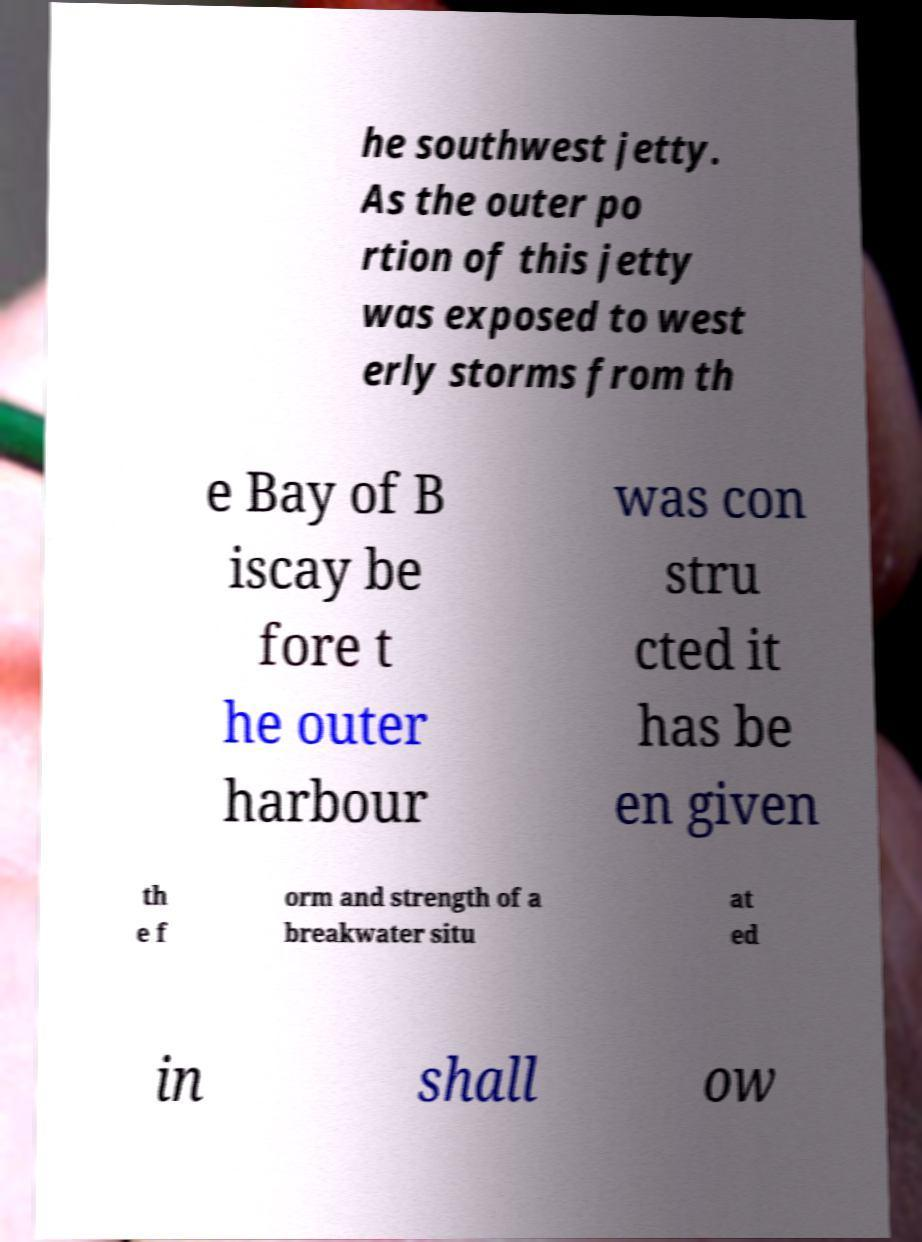Could you assist in decoding the text presented in this image and type it out clearly? he southwest jetty. As the outer po rtion of this jetty was exposed to west erly storms from th e Bay of B iscay be fore t he outer harbour was con stru cted it has be en given th e f orm and strength of a breakwater situ at ed in shall ow 